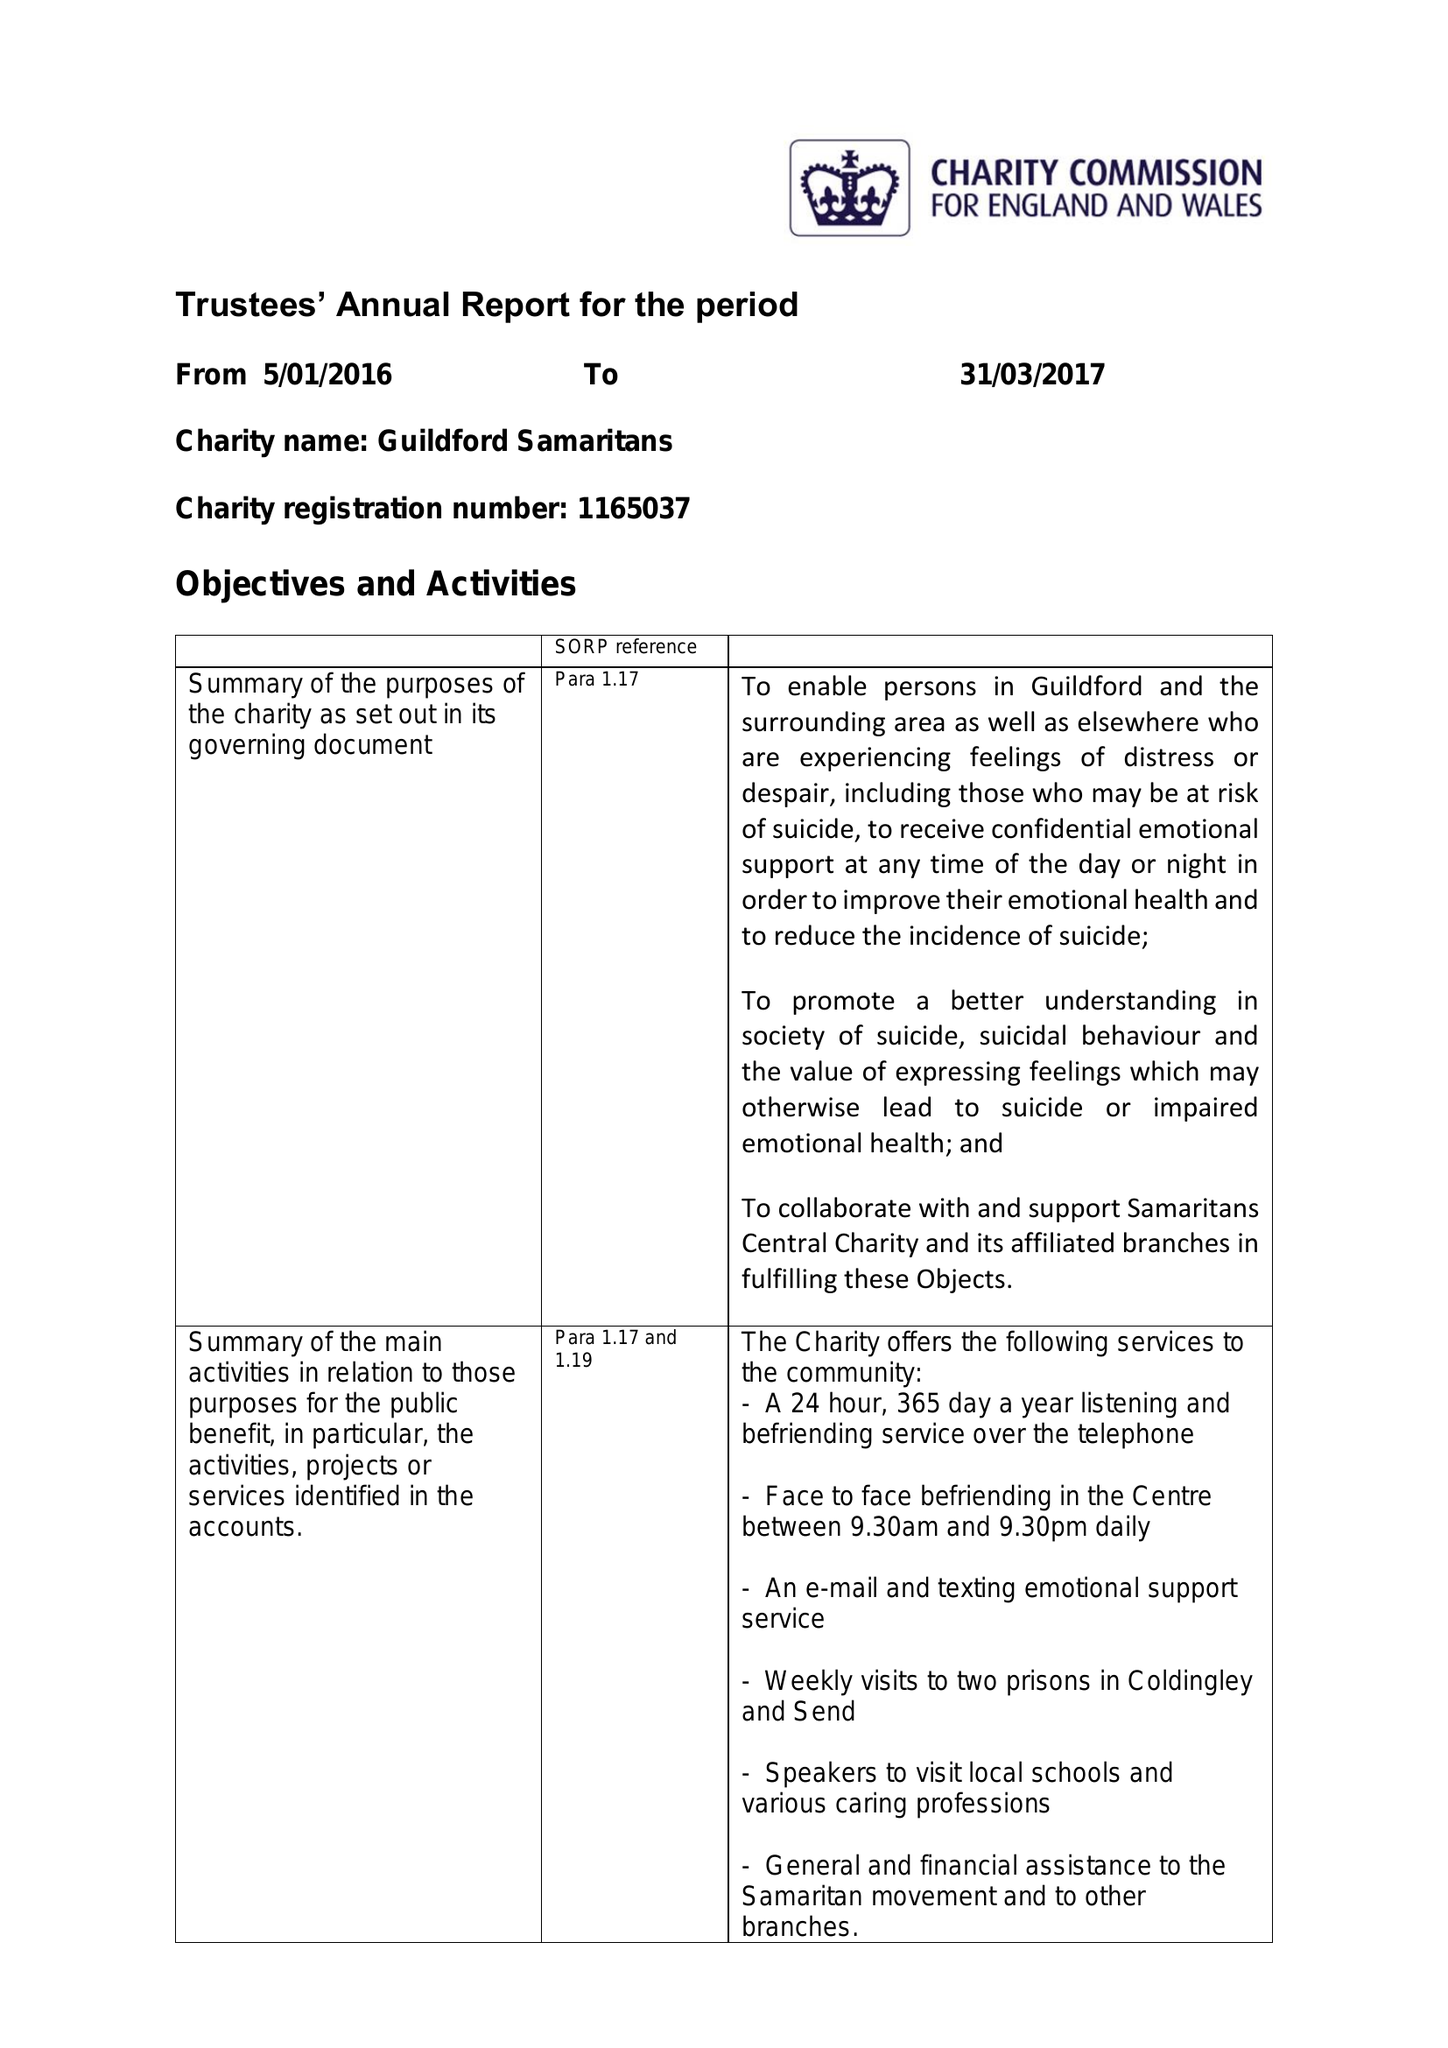What is the value for the charity_number?
Answer the question using a single word or phrase. 1165037 